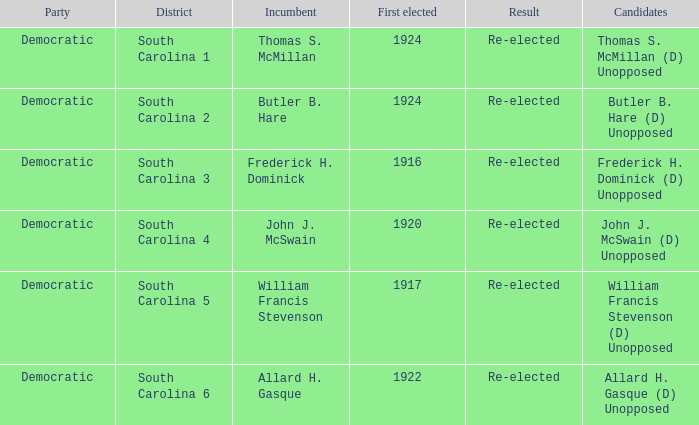What is the result for thomas s. mcmillan? Re-elected. 